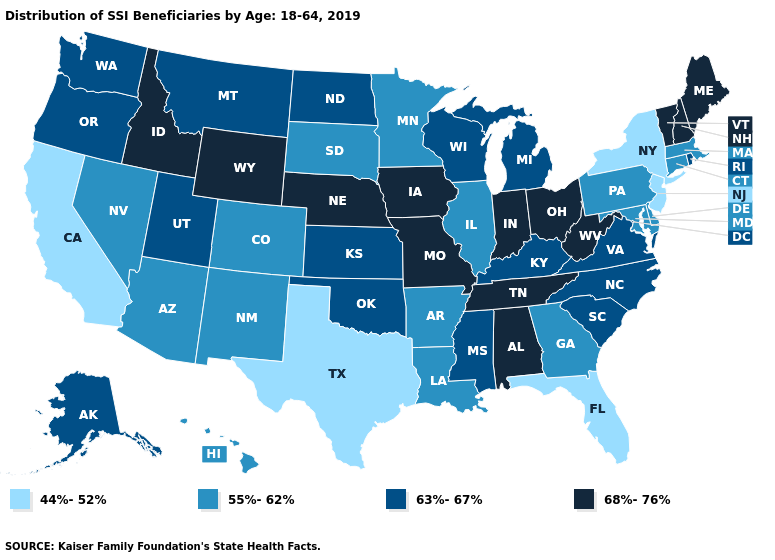Does Georgia have the same value as Kentucky?
Keep it brief. No. What is the lowest value in the USA?
Keep it brief. 44%-52%. Name the states that have a value in the range 63%-67%?
Keep it brief. Alaska, Kansas, Kentucky, Michigan, Mississippi, Montana, North Carolina, North Dakota, Oklahoma, Oregon, Rhode Island, South Carolina, Utah, Virginia, Washington, Wisconsin. What is the value of Rhode Island?
Keep it brief. 63%-67%. What is the lowest value in the Northeast?
Be succinct. 44%-52%. Name the states that have a value in the range 68%-76%?
Write a very short answer. Alabama, Idaho, Indiana, Iowa, Maine, Missouri, Nebraska, New Hampshire, Ohio, Tennessee, Vermont, West Virginia, Wyoming. What is the lowest value in states that border California?
Keep it brief. 55%-62%. How many symbols are there in the legend?
Short answer required. 4. What is the value of Illinois?
Short answer required. 55%-62%. What is the value of Massachusetts?
Be succinct. 55%-62%. Which states have the lowest value in the West?
Keep it brief. California. Does Massachusetts have the same value as North Carolina?
Concise answer only. No. What is the lowest value in the USA?
Quick response, please. 44%-52%. Name the states that have a value in the range 44%-52%?
Concise answer only. California, Florida, New Jersey, New York, Texas. Does Maine have the highest value in the Northeast?
Keep it brief. Yes. 